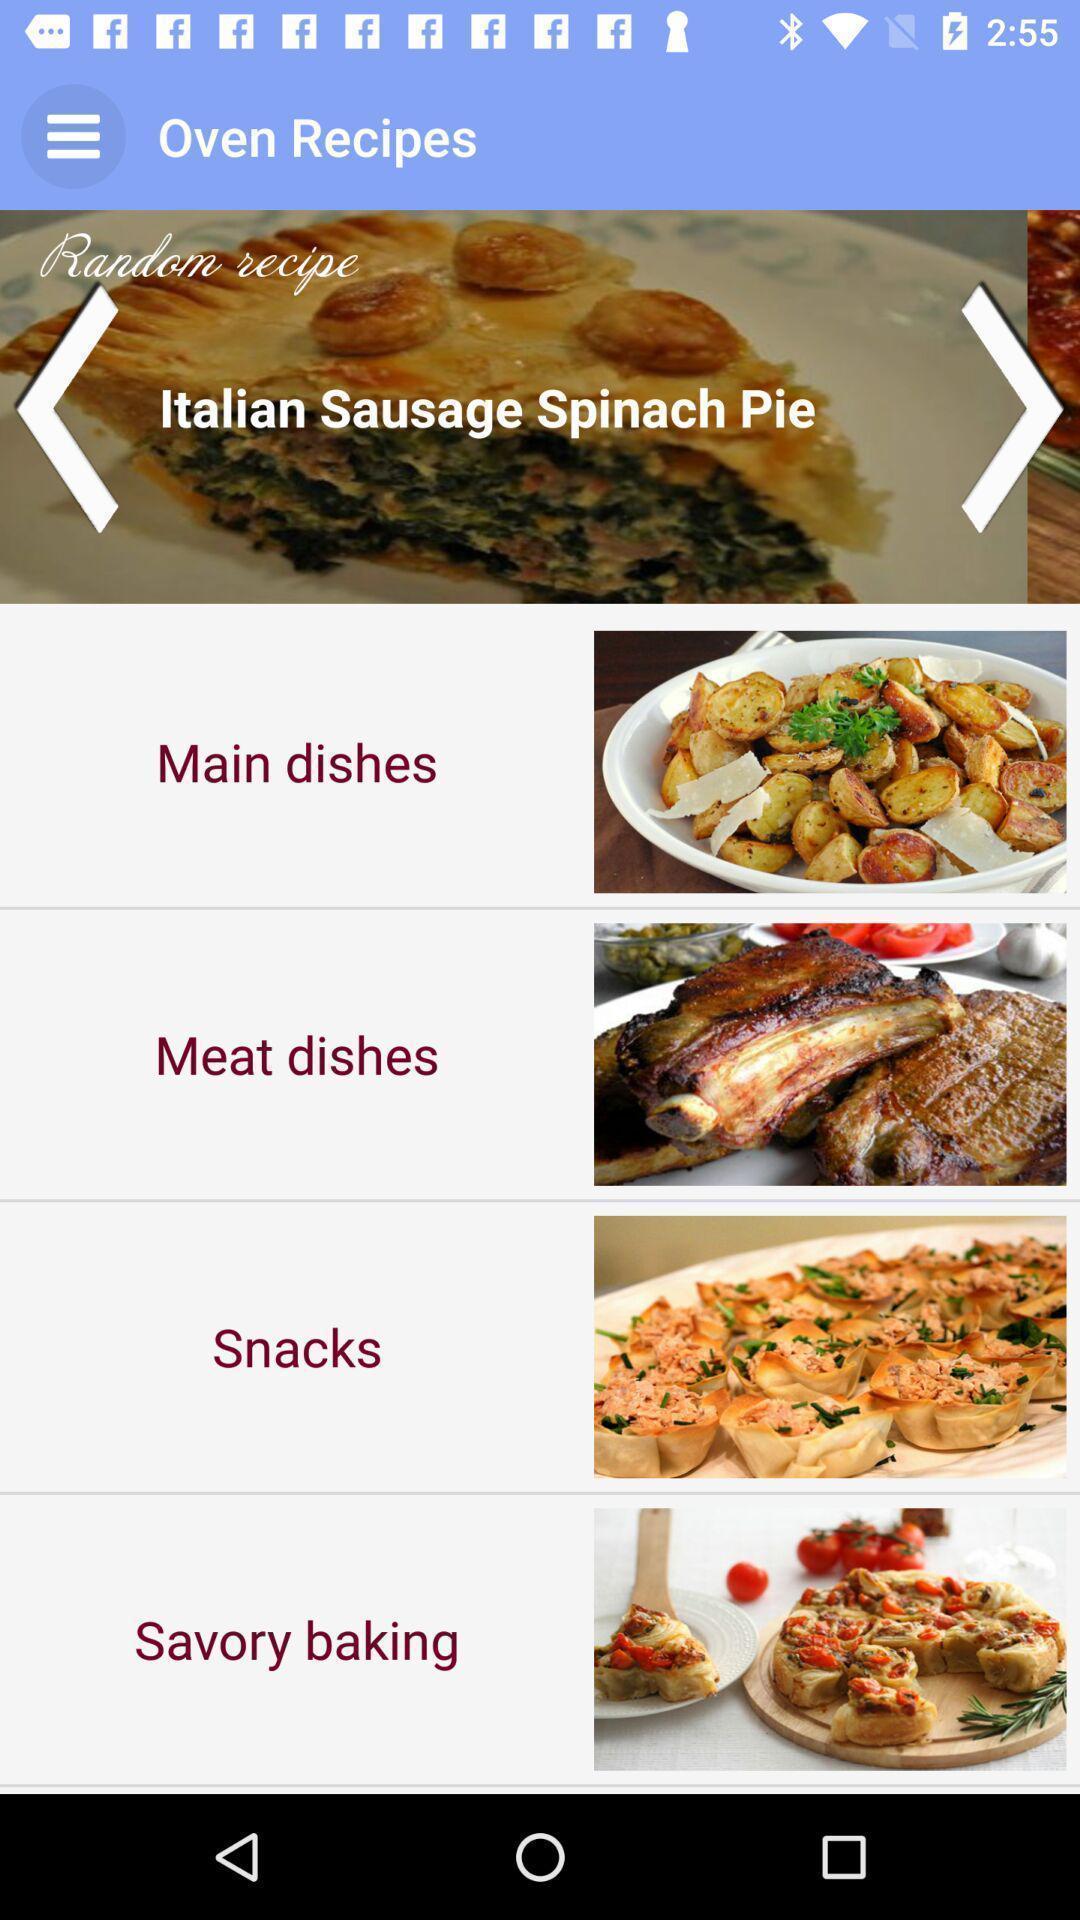Explain the elements present in this screenshot. Screen shows recipes page in food application. 